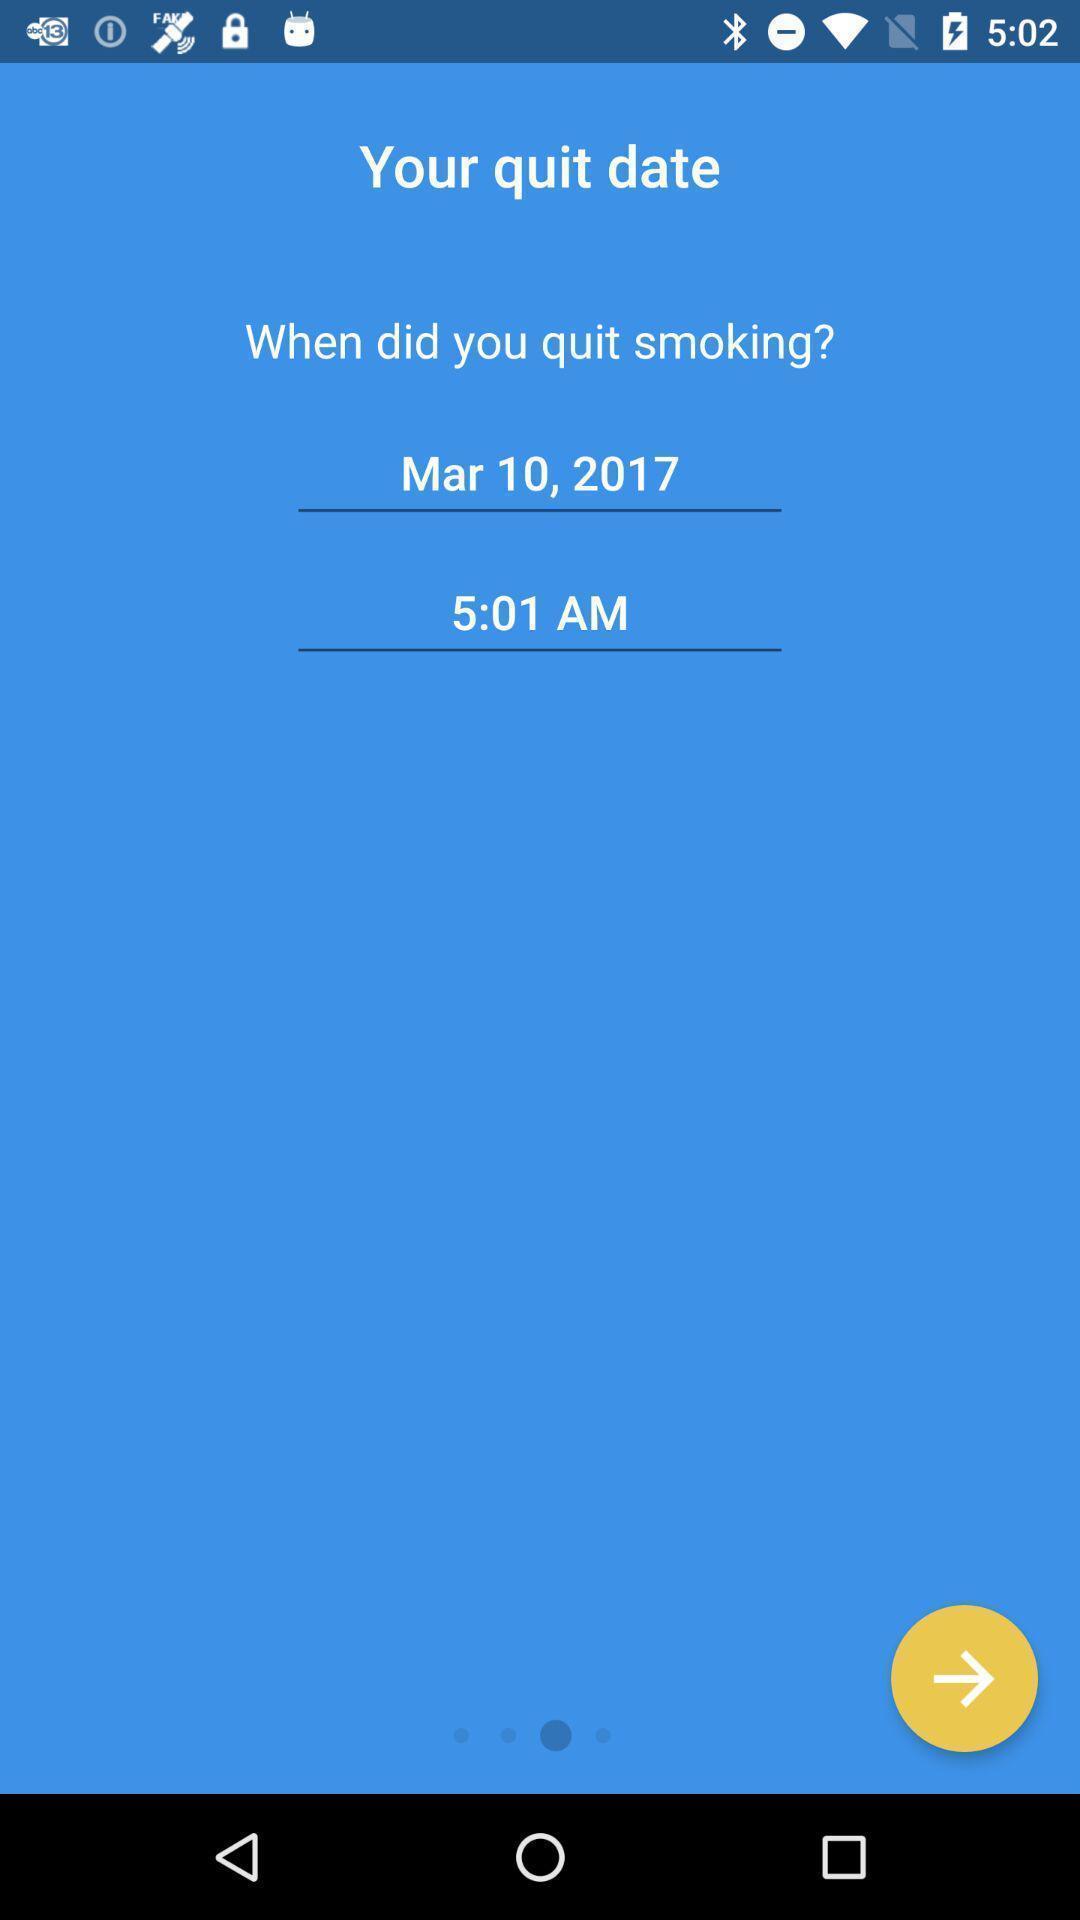Describe this image in words. Screen displaying quit date. 